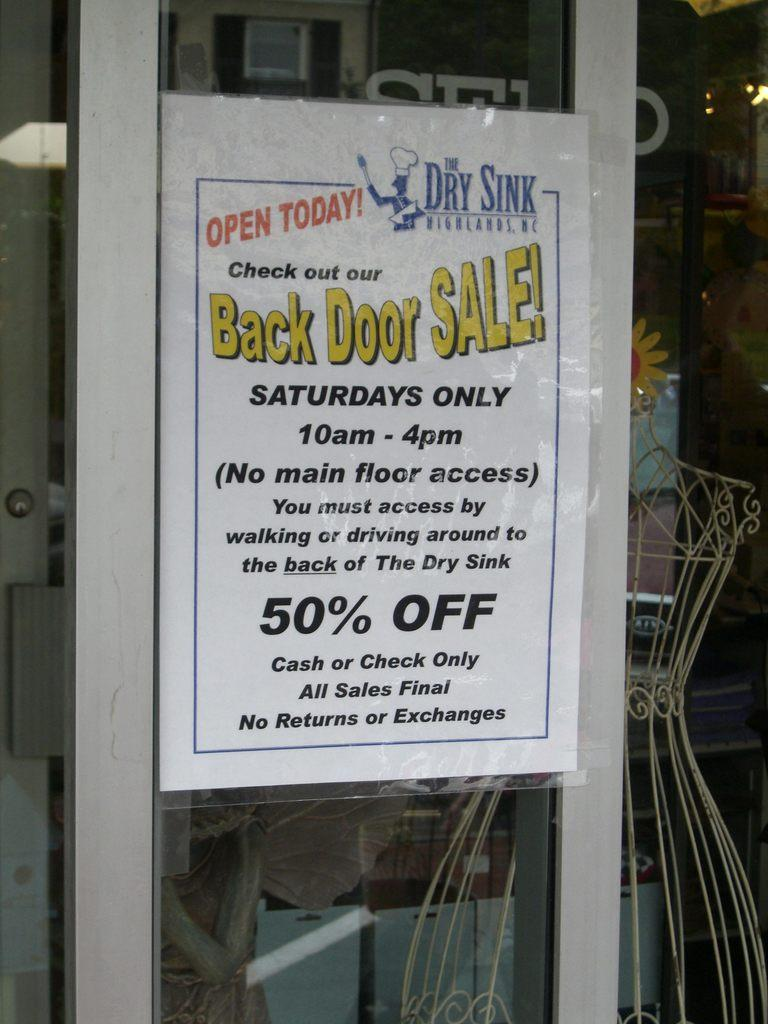What is present on the glass door in the image? There is a poster on the glass door in the image. What can be found on the poster? The poster has text on it. How is the poster attached to the glass door? The poster is attached to the glass door. What type of plastic material can be seen on the poster in the image? There is no plastic material present on the poster in the image. How does the poster respond when touched in the image? The poster is not a responsive object, so it does not respond when touched in the image. 